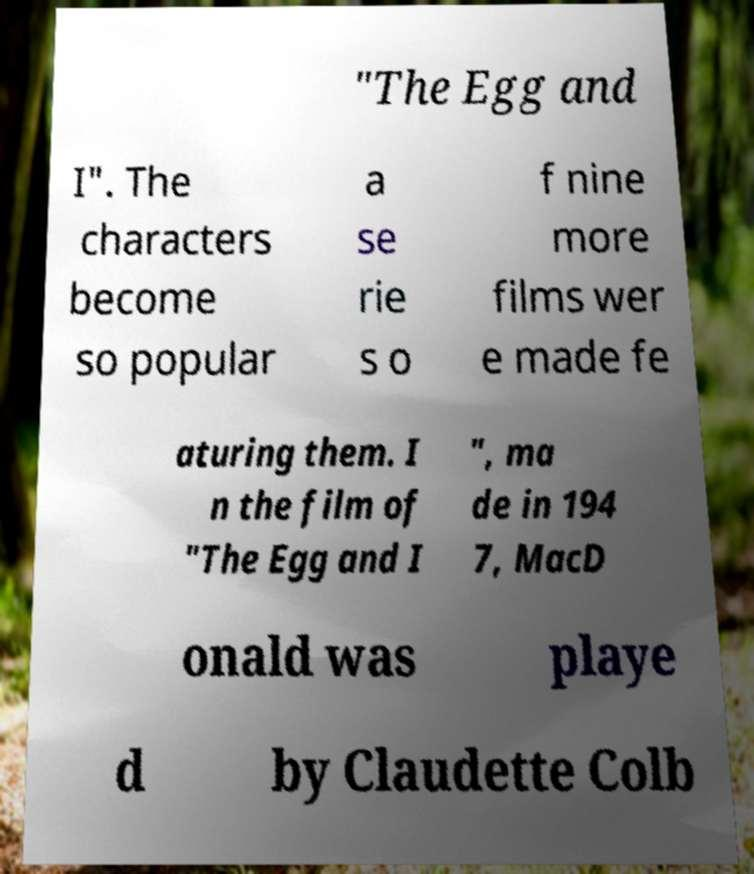There's text embedded in this image that I need extracted. Can you transcribe it verbatim? "The Egg and I". The characters become so popular a se rie s o f nine more films wer e made fe aturing them. I n the film of "The Egg and I ", ma de in 194 7, MacD onald was playe d by Claudette Colb 